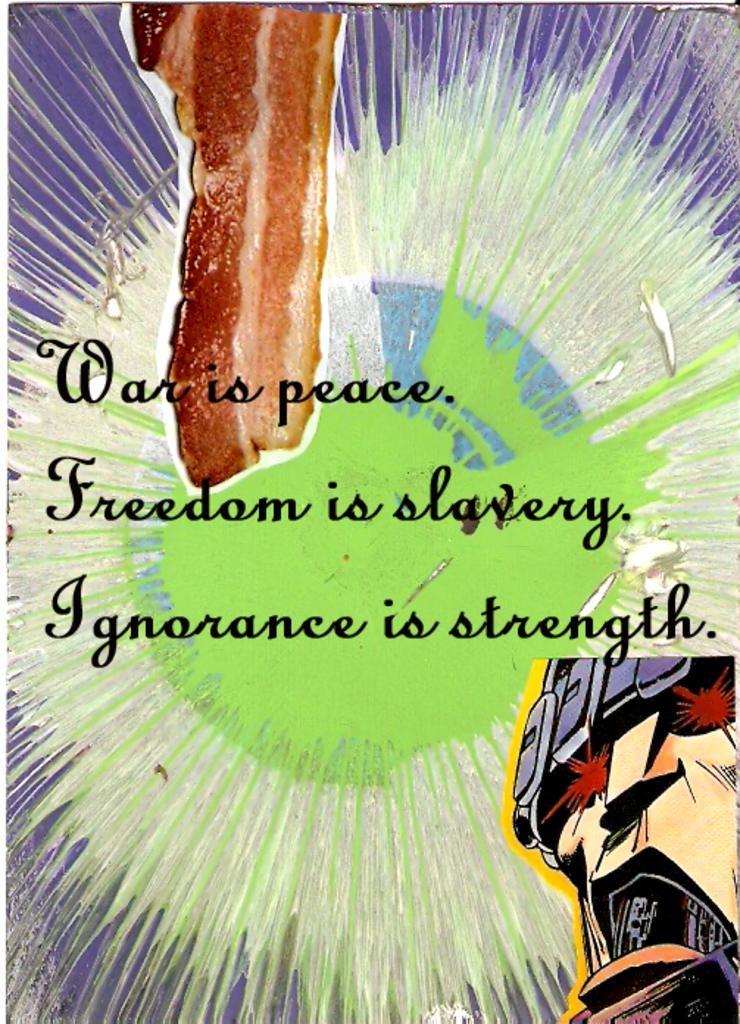What is peace?
Provide a succinct answer. War. What is slavery?
Offer a very short reply. Freedom. 